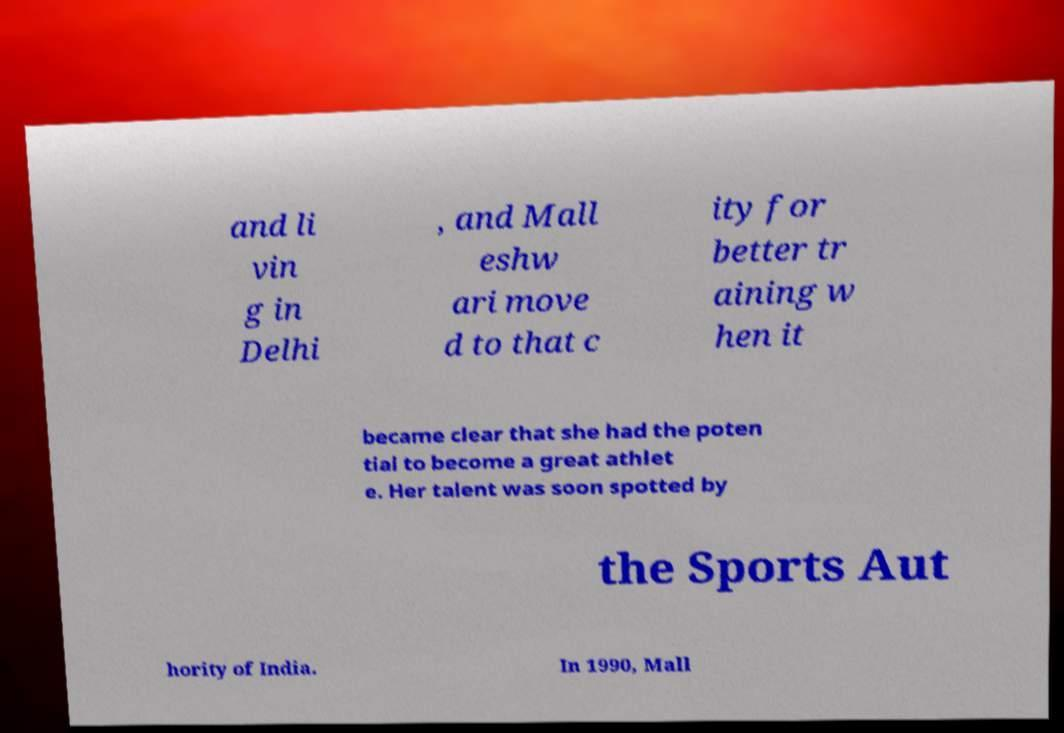Could you assist in decoding the text presented in this image and type it out clearly? and li vin g in Delhi , and Mall eshw ari move d to that c ity for better tr aining w hen it became clear that she had the poten tial to become a great athlet e. Her talent was soon spotted by the Sports Aut hority of India. In 1990, Mall 